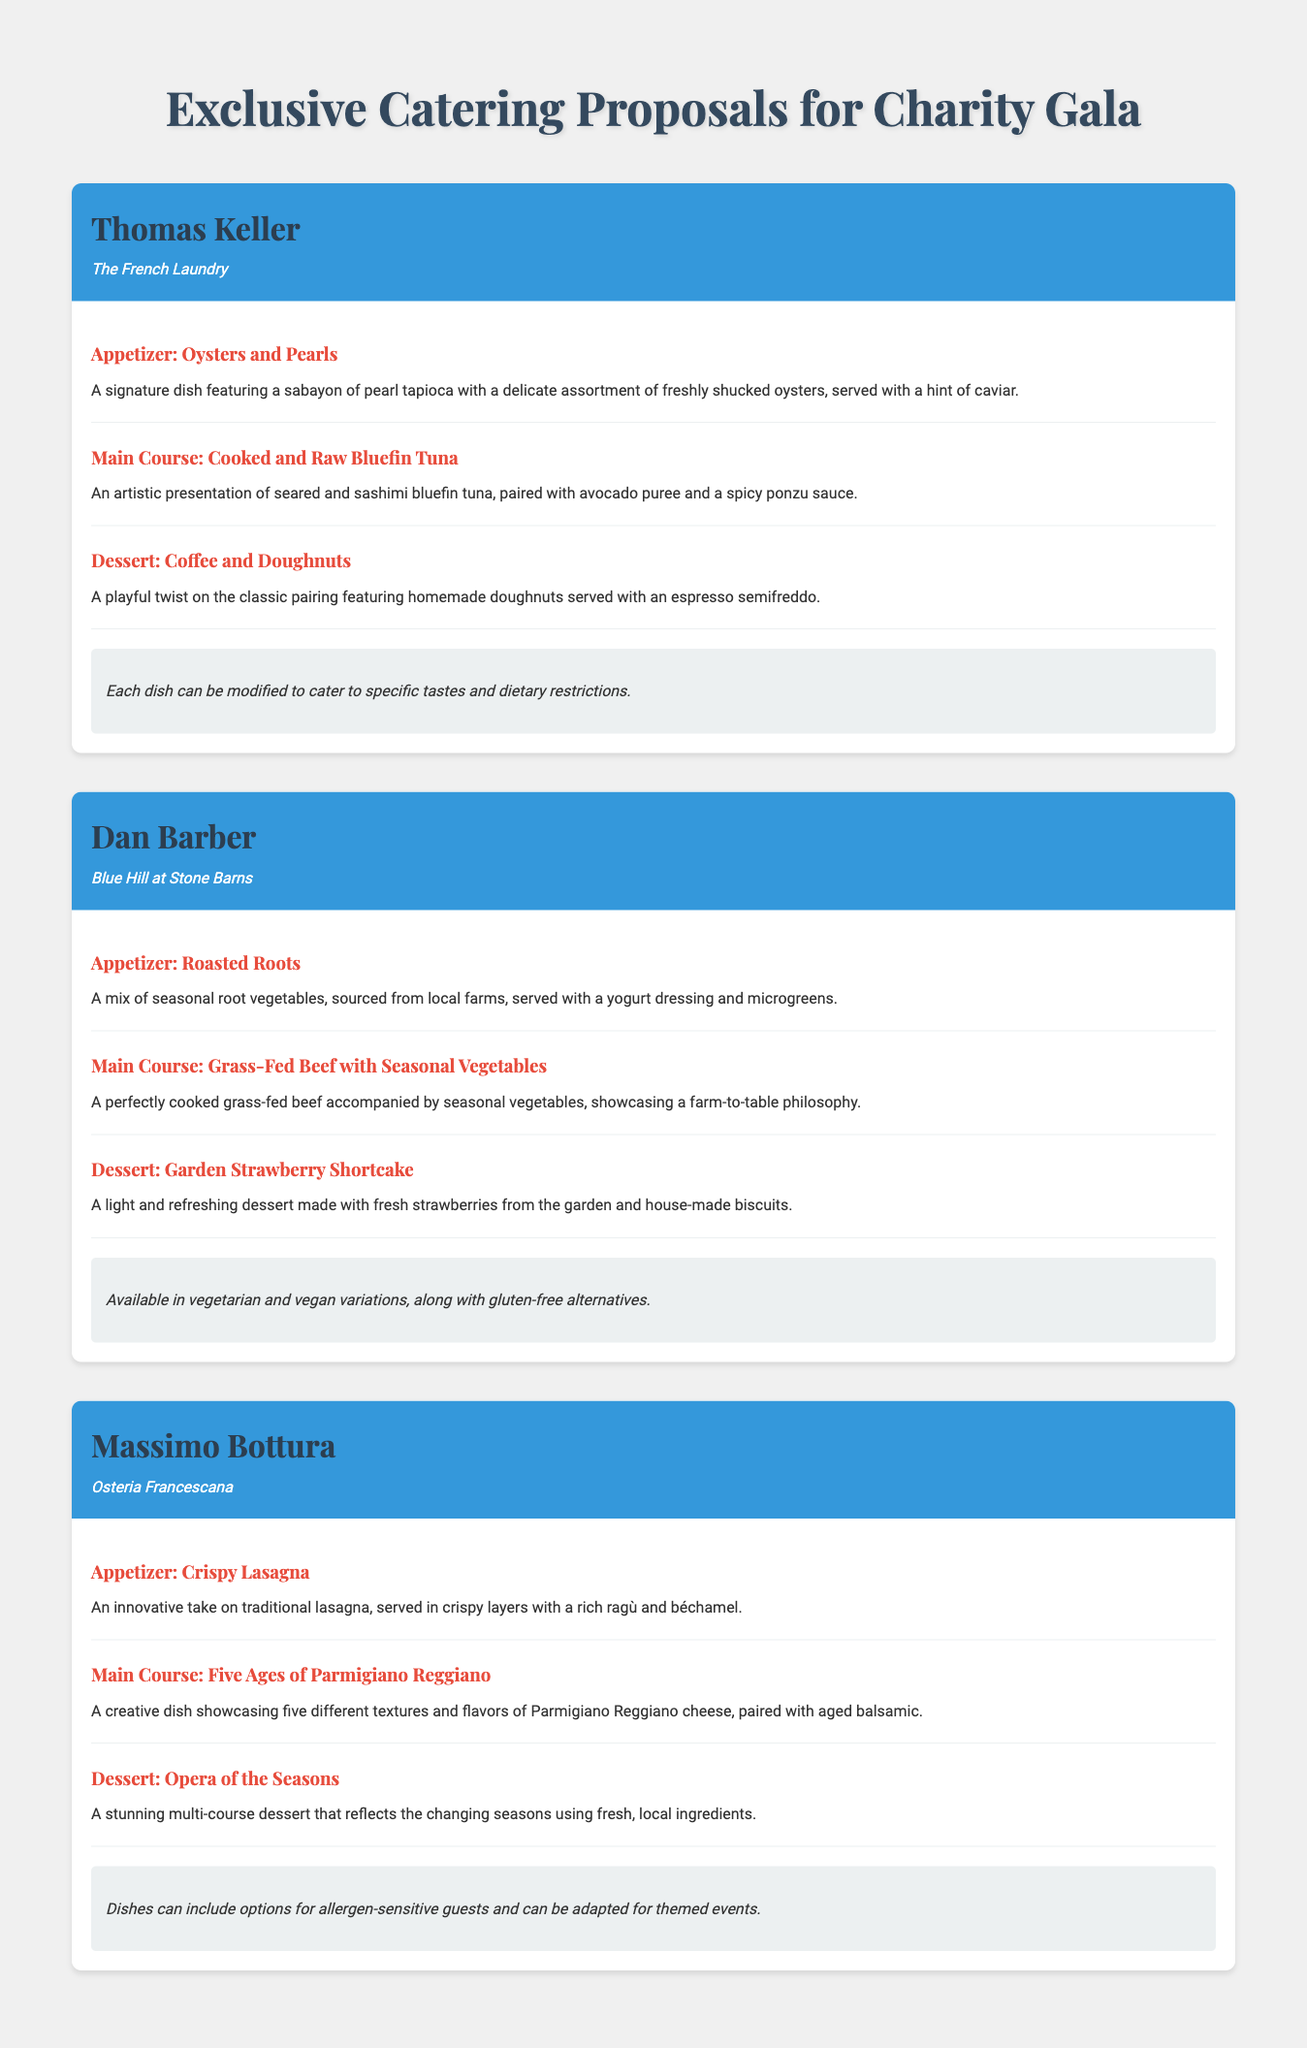What is the name of the chef featured first? The first chef listed in the document is Thomas Keller.
Answer: Thomas Keller What is the dessert option offered by Dan Barber? Dan Barber's dessert is Garden Strawberry Shortcake, as stated in the menu section.
Answer: Garden Strawberry Shortcake How many courses are included in Massimo Bottura's menu? Each chef offers three courses: appetizer, main course, and dessert, so Massimo Bottura has three courses.
Answer: Three courses What ingredient is highlighted in Thomas Keller's main course? The main course from Thomas Keller features bluefin tuna as the key ingredient.
Answer: Bluefin tuna What dietary options does Dan Barber's menu provide? Dan Barber's menu indicates it is available in vegetarian, vegan, and gluten-free variations.
Answer: Vegetarian and vegan options, gluten-free alternatives Which chef is associated with Osteria Francescana? The chef linked with Osteria Francescana in the document is Massimo Bottura.
Answer: Massimo Bottura What type of vegetables does Dan Barber emphasize in his appetizer? Dan Barber's appetizer focuses on seasonal root vegetables sourced from local farms.
Answer: Seasonal root vegetables What unique feature does Massimo Bottura's dessert have? Massimo Bottura's dessert, Opera of the Seasons, reflects the changing seasons.
Answer: Reflects the changing seasons 